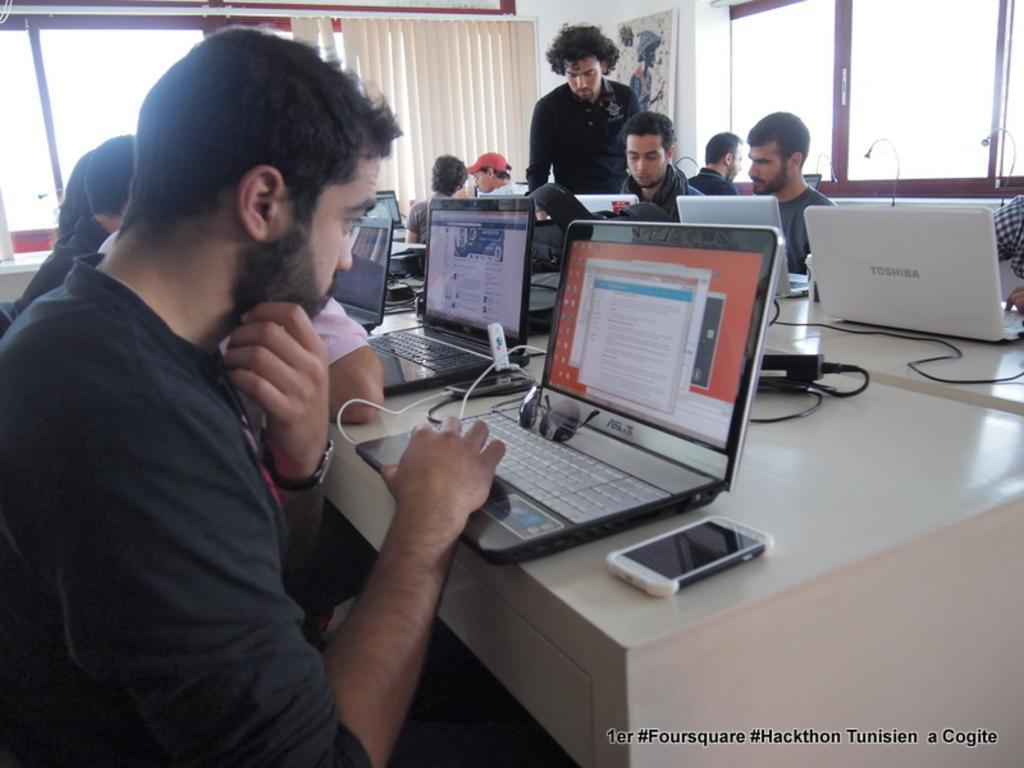Please provide a concise description of this image. In this image, there is a white color table on that table there are some laptops kept and there is a mobile which is in white color, there are some people sitting on the chairs around the table, in the background there is a glass window which is in brown color, there is a curtain which is in white color. 